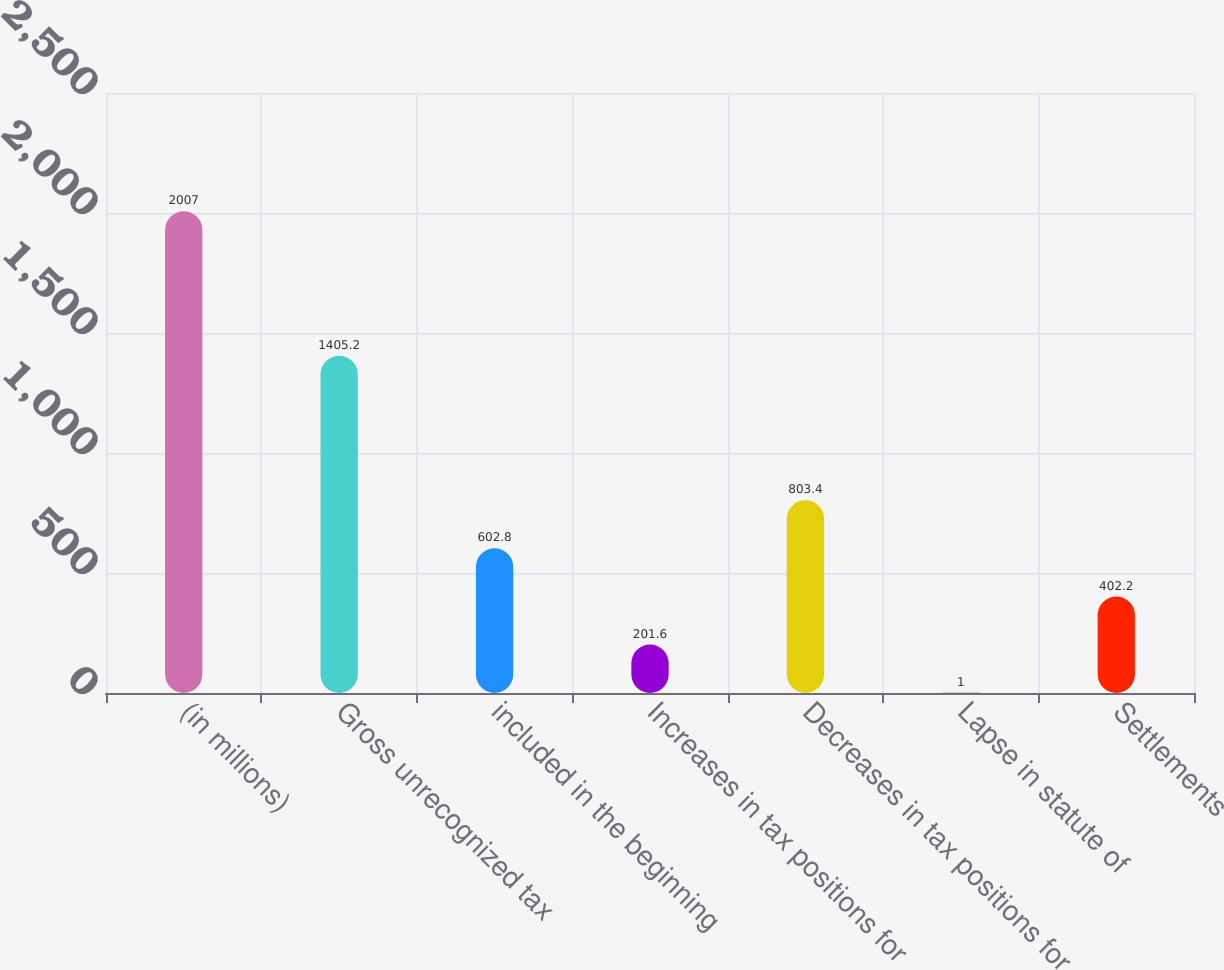Convert chart. <chart><loc_0><loc_0><loc_500><loc_500><bar_chart><fcel>(in millions)<fcel>Gross unrecognized tax<fcel>included in the beginning<fcel>Increases in tax positions for<fcel>Decreases in tax positions for<fcel>Lapse in statute of<fcel>Settlements<nl><fcel>2007<fcel>1405.2<fcel>602.8<fcel>201.6<fcel>803.4<fcel>1<fcel>402.2<nl></chart> 